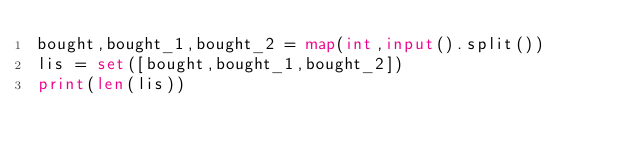Convert code to text. <code><loc_0><loc_0><loc_500><loc_500><_Python_>bought,bought_1,bought_2 = map(int,input().split())
lis = set([bought,bought_1,bought_2])
print(len(lis))

    </code> 